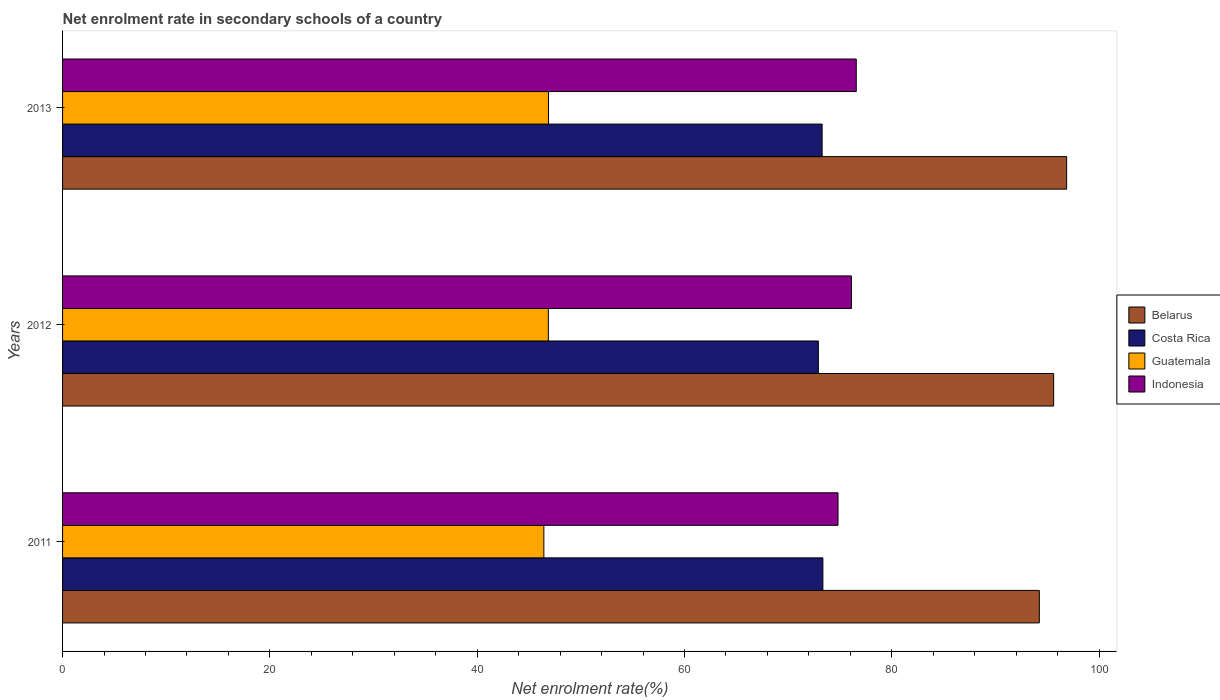How many bars are there on the 1st tick from the bottom?
Offer a terse response. 4. What is the net enrolment rate in secondary schools in Indonesia in 2011?
Your response must be concise. 74.81. Across all years, what is the maximum net enrolment rate in secondary schools in Costa Rica?
Provide a succinct answer. 73.35. Across all years, what is the minimum net enrolment rate in secondary schools in Belarus?
Offer a terse response. 94.23. In which year was the net enrolment rate in secondary schools in Belarus maximum?
Keep it short and to the point. 2013. In which year was the net enrolment rate in secondary schools in Costa Rica minimum?
Your answer should be compact. 2012. What is the total net enrolment rate in secondary schools in Guatemala in the graph?
Offer a very short reply. 140.18. What is the difference between the net enrolment rate in secondary schools in Costa Rica in 2011 and that in 2013?
Offer a very short reply. 0.07. What is the difference between the net enrolment rate in secondary schools in Costa Rica in 2013 and the net enrolment rate in secondary schools in Belarus in 2012?
Offer a terse response. -22.33. What is the average net enrolment rate in secondary schools in Indonesia per year?
Make the answer very short. 75.83. In the year 2011, what is the difference between the net enrolment rate in secondary schools in Indonesia and net enrolment rate in secondary schools in Guatemala?
Ensure brevity in your answer.  28.38. In how many years, is the net enrolment rate in secondary schools in Belarus greater than 12 %?
Provide a succinct answer. 3. What is the ratio of the net enrolment rate in secondary schools in Costa Rica in 2011 to that in 2013?
Provide a succinct answer. 1. Is the net enrolment rate in secondary schools in Indonesia in 2011 less than that in 2013?
Your answer should be very brief. Yes. Is the difference between the net enrolment rate in secondary schools in Indonesia in 2012 and 2013 greater than the difference between the net enrolment rate in secondary schools in Guatemala in 2012 and 2013?
Provide a succinct answer. No. What is the difference between the highest and the second highest net enrolment rate in secondary schools in Guatemala?
Your answer should be very brief. 0.02. What is the difference between the highest and the lowest net enrolment rate in secondary schools in Guatemala?
Keep it short and to the point. 0.45. Is the sum of the net enrolment rate in secondary schools in Guatemala in 2012 and 2013 greater than the maximum net enrolment rate in secondary schools in Costa Rica across all years?
Keep it short and to the point. Yes. What does the 2nd bar from the top in 2013 represents?
Provide a short and direct response. Guatemala. What does the 2nd bar from the bottom in 2012 represents?
Provide a succinct answer. Costa Rica. How many bars are there?
Give a very brief answer. 12. How many years are there in the graph?
Provide a short and direct response. 3. What is the difference between two consecutive major ticks on the X-axis?
Your answer should be very brief. 20. Are the values on the major ticks of X-axis written in scientific E-notation?
Give a very brief answer. No. Does the graph contain any zero values?
Provide a succinct answer. No. Does the graph contain grids?
Offer a very short reply. No. What is the title of the graph?
Your answer should be very brief. Net enrolment rate in secondary schools of a country. What is the label or title of the X-axis?
Your response must be concise. Net enrolment rate(%). What is the Net enrolment rate(%) in Belarus in 2011?
Keep it short and to the point. 94.23. What is the Net enrolment rate(%) in Costa Rica in 2011?
Give a very brief answer. 73.35. What is the Net enrolment rate(%) in Guatemala in 2011?
Offer a very short reply. 46.43. What is the Net enrolment rate(%) of Indonesia in 2011?
Your response must be concise. 74.81. What is the Net enrolment rate(%) of Belarus in 2012?
Make the answer very short. 95.61. What is the Net enrolment rate(%) in Costa Rica in 2012?
Provide a succinct answer. 72.91. What is the Net enrolment rate(%) in Guatemala in 2012?
Provide a short and direct response. 46.87. What is the Net enrolment rate(%) in Indonesia in 2012?
Provide a succinct answer. 76.1. What is the Net enrolment rate(%) in Belarus in 2013?
Offer a very short reply. 96.86. What is the Net enrolment rate(%) in Costa Rica in 2013?
Provide a short and direct response. 73.28. What is the Net enrolment rate(%) of Guatemala in 2013?
Keep it short and to the point. 46.88. What is the Net enrolment rate(%) of Indonesia in 2013?
Offer a very short reply. 76.57. Across all years, what is the maximum Net enrolment rate(%) of Belarus?
Make the answer very short. 96.86. Across all years, what is the maximum Net enrolment rate(%) in Costa Rica?
Make the answer very short. 73.35. Across all years, what is the maximum Net enrolment rate(%) in Guatemala?
Give a very brief answer. 46.88. Across all years, what is the maximum Net enrolment rate(%) in Indonesia?
Keep it short and to the point. 76.57. Across all years, what is the minimum Net enrolment rate(%) of Belarus?
Give a very brief answer. 94.23. Across all years, what is the minimum Net enrolment rate(%) of Costa Rica?
Ensure brevity in your answer.  72.91. Across all years, what is the minimum Net enrolment rate(%) in Guatemala?
Your response must be concise. 46.43. Across all years, what is the minimum Net enrolment rate(%) in Indonesia?
Make the answer very short. 74.81. What is the total Net enrolment rate(%) in Belarus in the graph?
Provide a succinct answer. 286.7. What is the total Net enrolment rate(%) of Costa Rica in the graph?
Ensure brevity in your answer.  219.54. What is the total Net enrolment rate(%) of Guatemala in the graph?
Make the answer very short. 140.18. What is the total Net enrolment rate(%) of Indonesia in the graph?
Your response must be concise. 227.48. What is the difference between the Net enrolment rate(%) of Belarus in 2011 and that in 2012?
Offer a terse response. -1.38. What is the difference between the Net enrolment rate(%) in Costa Rica in 2011 and that in 2012?
Provide a short and direct response. 0.43. What is the difference between the Net enrolment rate(%) in Guatemala in 2011 and that in 2012?
Give a very brief answer. -0.43. What is the difference between the Net enrolment rate(%) in Indonesia in 2011 and that in 2012?
Your answer should be compact. -1.29. What is the difference between the Net enrolment rate(%) of Belarus in 2011 and that in 2013?
Make the answer very short. -2.63. What is the difference between the Net enrolment rate(%) of Costa Rica in 2011 and that in 2013?
Your response must be concise. 0.07. What is the difference between the Net enrolment rate(%) of Guatemala in 2011 and that in 2013?
Your answer should be compact. -0.45. What is the difference between the Net enrolment rate(%) of Indonesia in 2011 and that in 2013?
Provide a short and direct response. -1.76. What is the difference between the Net enrolment rate(%) of Belarus in 2012 and that in 2013?
Provide a short and direct response. -1.25. What is the difference between the Net enrolment rate(%) of Costa Rica in 2012 and that in 2013?
Your response must be concise. -0.36. What is the difference between the Net enrolment rate(%) in Guatemala in 2012 and that in 2013?
Your response must be concise. -0.02. What is the difference between the Net enrolment rate(%) in Indonesia in 2012 and that in 2013?
Provide a short and direct response. -0.47. What is the difference between the Net enrolment rate(%) in Belarus in 2011 and the Net enrolment rate(%) in Costa Rica in 2012?
Provide a short and direct response. 21.32. What is the difference between the Net enrolment rate(%) in Belarus in 2011 and the Net enrolment rate(%) in Guatemala in 2012?
Ensure brevity in your answer.  47.36. What is the difference between the Net enrolment rate(%) in Belarus in 2011 and the Net enrolment rate(%) in Indonesia in 2012?
Ensure brevity in your answer.  18.13. What is the difference between the Net enrolment rate(%) in Costa Rica in 2011 and the Net enrolment rate(%) in Guatemala in 2012?
Offer a terse response. 26.48. What is the difference between the Net enrolment rate(%) of Costa Rica in 2011 and the Net enrolment rate(%) of Indonesia in 2012?
Your answer should be compact. -2.75. What is the difference between the Net enrolment rate(%) in Guatemala in 2011 and the Net enrolment rate(%) in Indonesia in 2012?
Make the answer very short. -29.67. What is the difference between the Net enrolment rate(%) of Belarus in 2011 and the Net enrolment rate(%) of Costa Rica in 2013?
Keep it short and to the point. 20.95. What is the difference between the Net enrolment rate(%) of Belarus in 2011 and the Net enrolment rate(%) of Guatemala in 2013?
Provide a short and direct response. 47.35. What is the difference between the Net enrolment rate(%) of Belarus in 2011 and the Net enrolment rate(%) of Indonesia in 2013?
Give a very brief answer. 17.66. What is the difference between the Net enrolment rate(%) of Costa Rica in 2011 and the Net enrolment rate(%) of Guatemala in 2013?
Provide a short and direct response. 26.47. What is the difference between the Net enrolment rate(%) of Costa Rica in 2011 and the Net enrolment rate(%) of Indonesia in 2013?
Provide a succinct answer. -3.22. What is the difference between the Net enrolment rate(%) in Guatemala in 2011 and the Net enrolment rate(%) in Indonesia in 2013?
Ensure brevity in your answer.  -30.14. What is the difference between the Net enrolment rate(%) of Belarus in 2012 and the Net enrolment rate(%) of Costa Rica in 2013?
Your answer should be compact. 22.33. What is the difference between the Net enrolment rate(%) of Belarus in 2012 and the Net enrolment rate(%) of Guatemala in 2013?
Your answer should be compact. 48.73. What is the difference between the Net enrolment rate(%) of Belarus in 2012 and the Net enrolment rate(%) of Indonesia in 2013?
Make the answer very short. 19.04. What is the difference between the Net enrolment rate(%) in Costa Rica in 2012 and the Net enrolment rate(%) in Guatemala in 2013?
Provide a succinct answer. 26.03. What is the difference between the Net enrolment rate(%) of Costa Rica in 2012 and the Net enrolment rate(%) of Indonesia in 2013?
Offer a very short reply. -3.66. What is the difference between the Net enrolment rate(%) in Guatemala in 2012 and the Net enrolment rate(%) in Indonesia in 2013?
Offer a terse response. -29.7. What is the average Net enrolment rate(%) in Belarus per year?
Your answer should be compact. 95.57. What is the average Net enrolment rate(%) in Costa Rica per year?
Your answer should be very brief. 73.18. What is the average Net enrolment rate(%) in Guatemala per year?
Keep it short and to the point. 46.73. What is the average Net enrolment rate(%) of Indonesia per year?
Make the answer very short. 75.83. In the year 2011, what is the difference between the Net enrolment rate(%) in Belarus and Net enrolment rate(%) in Costa Rica?
Your response must be concise. 20.88. In the year 2011, what is the difference between the Net enrolment rate(%) of Belarus and Net enrolment rate(%) of Guatemala?
Your response must be concise. 47.8. In the year 2011, what is the difference between the Net enrolment rate(%) in Belarus and Net enrolment rate(%) in Indonesia?
Give a very brief answer. 19.42. In the year 2011, what is the difference between the Net enrolment rate(%) of Costa Rica and Net enrolment rate(%) of Guatemala?
Provide a succinct answer. 26.92. In the year 2011, what is the difference between the Net enrolment rate(%) in Costa Rica and Net enrolment rate(%) in Indonesia?
Provide a short and direct response. -1.46. In the year 2011, what is the difference between the Net enrolment rate(%) of Guatemala and Net enrolment rate(%) of Indonesia?
Ensure brevity in your answer.  -28.38. In the year 2012, what is the difference between the Net enrolment rate(%) of Belarus and Net enrolment rate(%) of Costa Rica?
Provide a short and direct response. 22.7. In the year 2012, what is the difference between the Net enrolment rate(%) in Belarus and Net enrolment rate(%) in Guatemala?
Provide a succinct answer. 48.74. In the year 2012, what is the difference between the Net enrolment rate(%) in Belarus and Net enrolment rate(%) in Indonesia?
Provide a short and direct response. 19.51. In the year 2012, what is the difference between the Net enrolment rate(%) in Costa Rica and Net enrolment rate(%) in Guatemala?
Give a very brief answer. 26.05. In the year 2012, what is the difference between the Net enrolment rate(%) in Costa Rica and Net enrolment rate(%) in Indonesia?
Your response must be concise. -3.19. In the year 2012, what is the difference between the Net enrolment rate(%) in Guatemala and Net enrolment rate(%) in Indonesia?
Offer a very short reply. -29.24. In the year 2013, what is the difference between the Net enrolment rate(%) of Belarus and Net enrolment rate(%) of Costa Rica?
Offer a terse response. 23.59. In the year 2013, what is the difference between the Net enrolment rate(%) in Belarus and Net enrolment rate(%) in Guatemala?
Ensure brevity in your answer.  49.98. In the year 2013, what is the difference between the Net enrolment rate(%) of Belarus and Net enrolment rate(%) of Indonesia?
Offer a very short reply. 20.29. In the year 2013, what is the difference between the Net enrolment rate(%) of Costa Rica and Net enrolment rate(%) of Guatemala?
Your answer should be very brief. 26.39. In the year 2013, what is the difference between the Net enrolment rate(%) of Costa Rica and Net enrolment rate(%) of Indonesia?
Your answer should be compact. -3.29. In the year 2013, what is the difference between the Net enrolment rate(%) of Guatemala and Net enrolment rate(%) of Indonesia?
Make the answer very short. -29.69. What is the ratio of the Net enrolment rate(%) in Belarus in 2011 to that in 2012?
Keep it short and to the point. 0.99. What is the ratio of the Net enrolment rate(%) in Indonesia in 2011 to that in 2012?
Make the answer very short. 0.98. What is the ratio of the Net enrolment rate(%) in Belarus in 2011 to that in 2013?
Give a very brief answer. 0.97. What is the ratio of the Net enrolment rate(%) of Costa Rica in 2011 to that in 2013?
Make the answer very short. 1. What is the ratio of the Net enrolment rate(%) of Guatemala in 2011 to that in 2013?
Make the answer very short. 0.99. What is the ratio of the Net enrolment rate(%) of Indonesia in 2011 to that in 2013?
Your answer should be compact. 0.98. What is the ratio of the Net enrolment rate(%) in Belarus in 2012 to that in 2013?
Keep it short and to the point. 0.99. What is the difference between the highest and the second highest Net enrolment rate(%) of Belarus?
Keep it short and to the point. 1.25. What is the difference between the highest and the second highest Net enrolment rate(%) in Costa Rica?
Keep it short and to the point. 0.07. What is the difference between the highest and the second highest Net enrolment rate(%) in Guatemala?
Offer a very short reply. 0.02. What is the difference between the highest and the second highest Net enrolment rate(%) in Indonesia?
Make the answer very short. 0.47. What is the difference between the highest and the lowest Net enrolment rate(%) of Belarus?
Make the answer very short. 2.63. What is the difference between the highest and the lowest Net enrolment rate(%) of Costa Rica?
Provide a short and direct response. 0.43. What is the difference between the highest and the lowest Net enrolment rate(%) of Guatemala?
Provide a succinct answer. 0.45. What is the difference between the highest and the lowest Net enrolment rate(%) in Indonesia?
Your response must be concise. 1.76. 